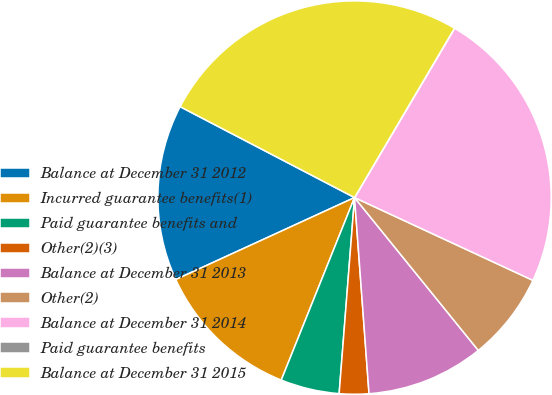Convert chart to OTSL. <chart><loc_0><loc_0><loc_500><loc_500><pie_chart><fcel>Balance at December 31 2012<fcel>Incurred guarantee benefits(1)<fcel>Paid guarantee benefits and<fcel>Other(2)(3)<fcel>Balance at December 31 2013<fcel>Other(2)<fcel>Balance at December 31 2014<fcel>Paid guarantee benefits<fcel>Balance at December 31 2015<nl><fcel>14.49%<fcel>12.08%<fcel>4.83%<fcel>2.42%<fcel>9.66%<fcel>7.25%<fcel>23.42%<fcel>0.01%<fcel>25.84%<nl></chart> 